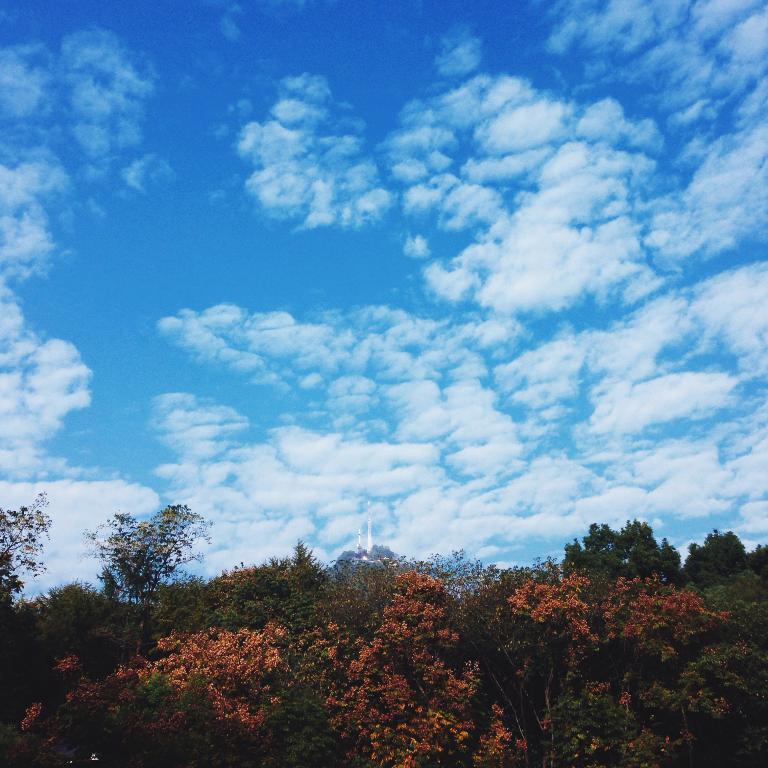How would you summarize this image in a sentence or two? There are trees and the sky is a bit cloudy. 